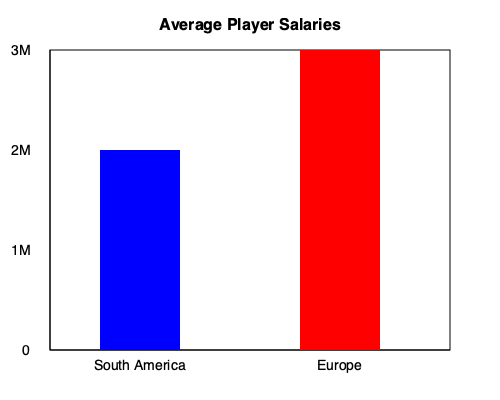Based on the chart comparing average player salaries in South American and European leagues, how much more does a player typically earn in Europe compared to South America? To find the difference in average salaries between European and South American leagues, we need to:

1. Identify the average salary for South American leagues:
   The blue bar shows $1M for South America.

2. Identify the average salary for European leagues:
   The red bar shows $2.5M for Europe.

3. Calculate the difference:
   $2.5M - $1M = $1.5M

Therefore, a player typically earns $1.5M more in European leagues compared to South American leagues.
Answer: $1.5 million 